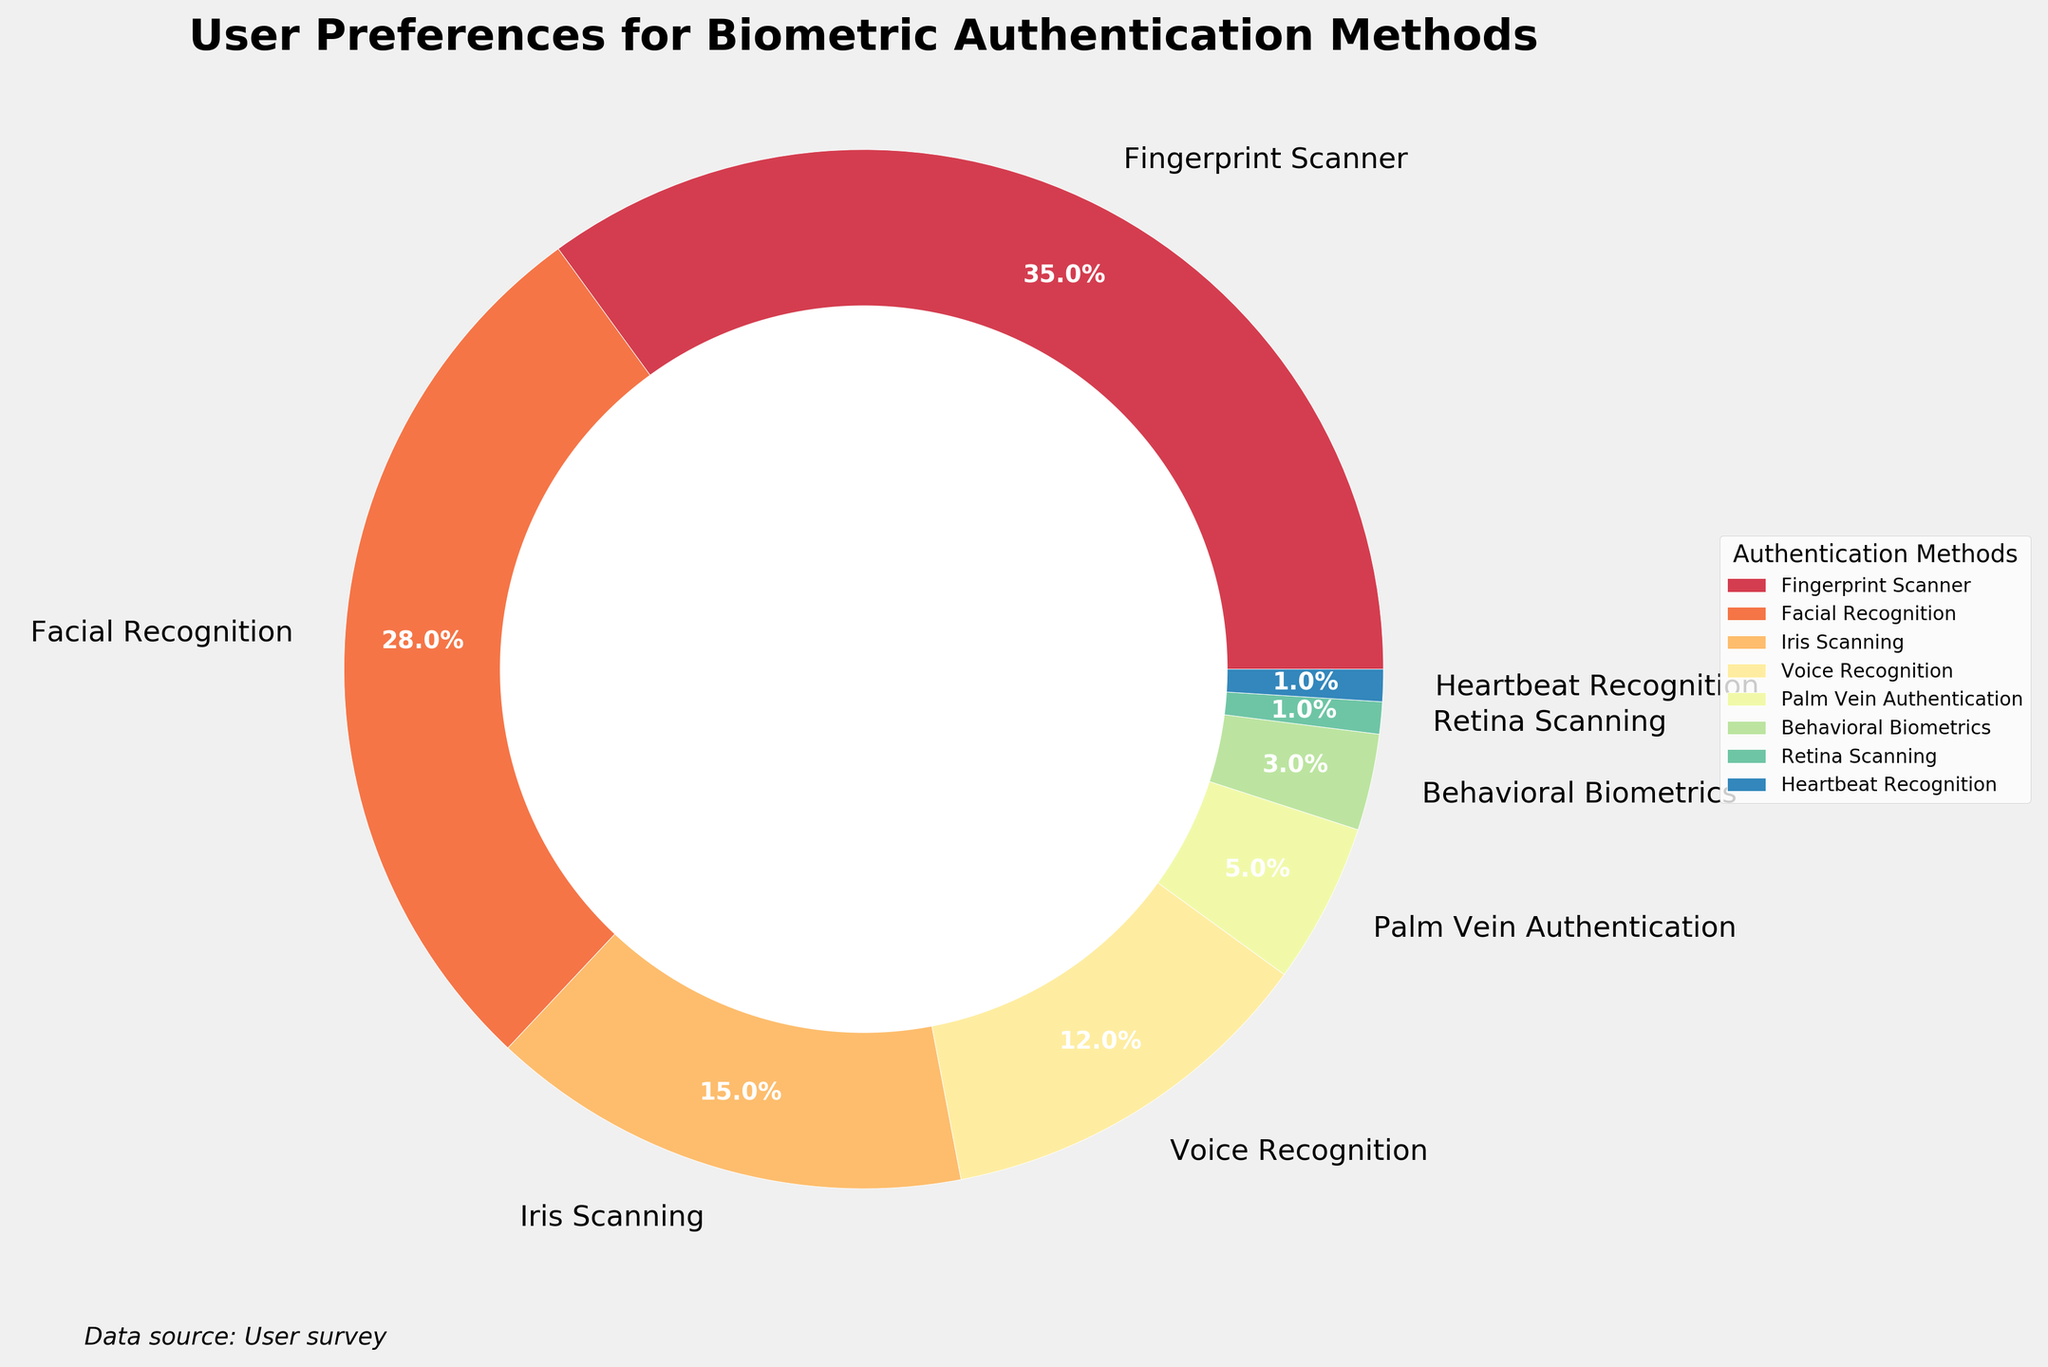What biometric method has the highest user preference? To find the method with the highest preference, look for the largest percentage in the chart. The Fingerprint Scanner has the highest percentage at 35%.
Answer: Fingerprint Scanner Which biometric methods have a user preference below 10%? Biometric methods below 10% can be identified by their corresponding wedges on the chart. Methods such as Palm Vein Authentication (5%), Behavioral Biometrics (3%), Retina Scanning (1%), and Heartbeat Recognition (1%) fall below 10%.
Answer: Palm Vein Authentication, Behavioral Biometrics, Retina Scanning, Heartbeat Recognition How much higher is the preference for Fingerprint Scanner compared to Iris Scanning? Look at the percentages for both methods. Fingerprint Scanner has 35%, and Iris Scanning has 15%. The difference is 35% - 15% = 20%.
Answer: 20% What is the combined percentage of Facial Recognition and Voice Recognition? Sum the percentages of the two methods: Facial Recognition (28%) and Voice Recognition (12%). Their combined percentage is 28% + 12% = 40%.
Answer: 40% Which two biometric methods have the least user preference? Identify the two smallest wedges or percentages in the chart. Retina Scanning and Heartbeat Recognition both have a preference of 1%.
Answer: Retina Scanning, Heartbeat Recognition What percentage of users prefer biometric methods other than Fingerprint Scanner and Facial Recognition combined? First, sum the percentages of Fingerprint Scanner (35%) and Facial Recognition (28%). Then subtract this sum from 100%: 100% - (35% + 28%) = 100% - 63% = 37%.
Answer: 37% Is Voice Recognition preferred more than Palm Vein Authentication? Compare their percentages. Voice Recognition has 12%, whereas Palm Vein Authentication has 5%, making Voice Recognition more preferred.
Answer: Yes What is the average preference percentage for all biometric methods listed? Sum all the preference percentages: 35% + 28% + 15% + 12% + 5% + 3% + 1% + 1% = 100%. There are 8 methods, so the average is 100% / 8 = 12.5%.
Answer: 12.5% Which biometric method has a preference closest to the average preference? The average preference is 12.5%. Compare each method's preference to see which is the closest: 12% for Voice Recognition is closest to 12.5%.
Answer: Voice Recognition 